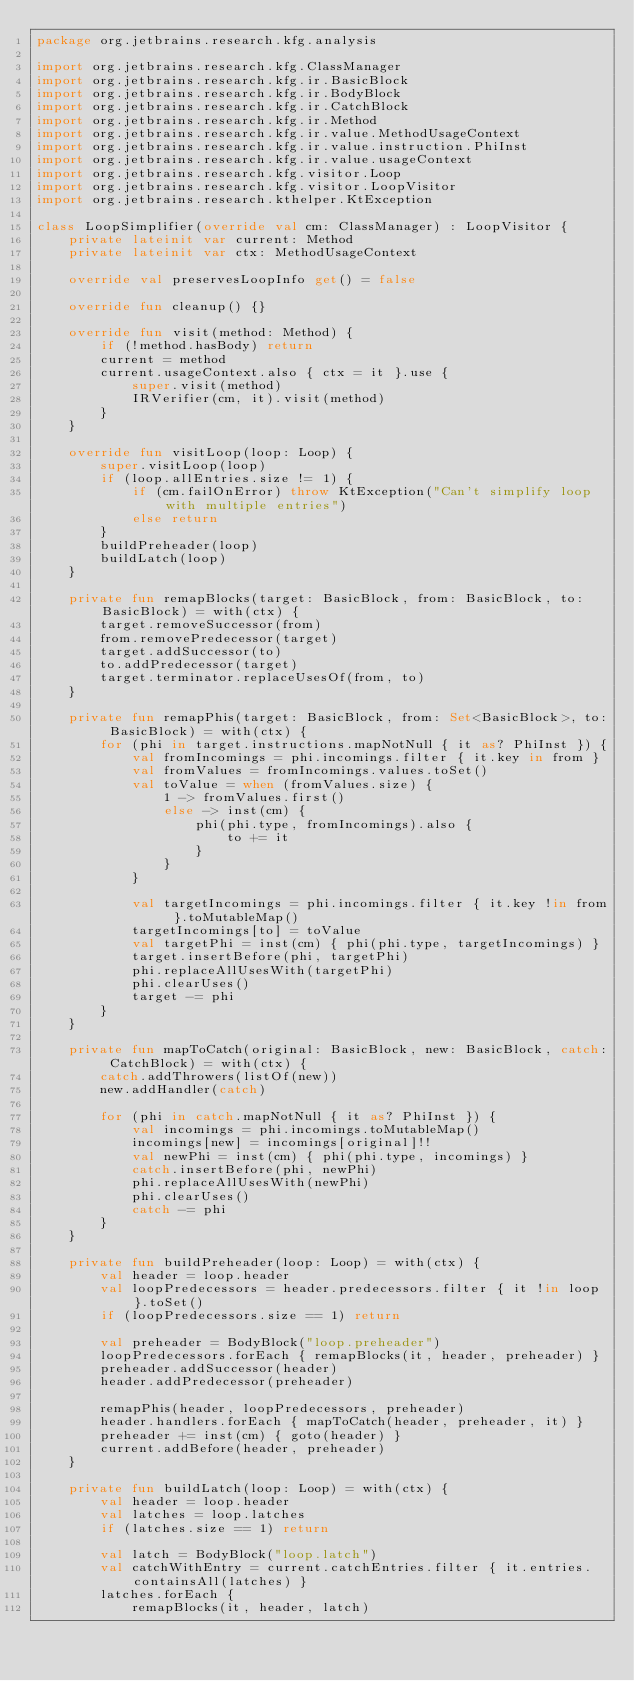<code> <loc_0><loc_0><loc_500><loc_500><_Kotlin_>package org.jetbrains.research.kfg.analysis

import org.jetbrains.research.kfg.ClassManager
import org.jetbrains.research.kfg.ir.BasicBlock
import org.jetbrains.research.kfg.ir.BodyBlock
import org.jetbrains.research.kfg.ir.CatchBlock
import org.jetbrains.research.kfg.ir.Method
import org.jetbrains.research.kfg.ir.value.MethodUsageContext
import org.jetbrains.research.kfg.ir.value.instruction.PhiInst
import org.jetbrains.research.kfg.ir.value.usageContext
import org.jetbrains.research.kfg.visitor.Loop
import org.jetbrains.research.kfg.visitor.LoopVisitor
import org.jetbrains.research.kthelper.KtException

class LoopSimplifier(override val cm: ClassManager) : LoopVisitor {
    private lateinit var current: Method
    private lateinit var ctx: MethodUsageContext

    override val preservesLoopInfo get() = false

    override fun cleanup() {}

    override fun visit(method: Method) {
        if (!method.hasBody) return
        current = method
        current.usageContext.also { ctx = it }.use {
            super.visit(method)
            IRVerifier(cm, it).visit(method)
        }
    }

    override fun visitLoop(loop: Loop) {
        super.visitLoop(loop)
        if (loop.allEntries.size != 1) {
            if (cm.failOnError) throw KtException("Can't simplify loop with multiple entries")
            else return
        }
        buildPreheader(loop)
        buildLatch(loop)
    }

    private fun remapBlocks(target: BasicBlock, from: BasicBlock, to: BasicBlock) = with(ctx) {
        target.removeSuccessor(from)
        from.removePredecessor(target)
        target.addSuccessor(to)
        to.addPredecessor(target)
        target.terminator.replaceUsesOf(from, to)
    }

    private fun remapPhis(target: BasicBlock, from: Set<BasicBlock>, to: BasicBlock) = with(ctx) {
        for (phi in target.instructions.mapNotNull { it as? PhiInst }) {
            val fromIncomings = phi.incomings.filter { it.key in from }
            val fromValues = fromIncomings.values.toSet()
            val toValue = when (fromValues.size) {
                1 -> fromValues.first()
                else -> inst(cm) {
                    phi(phi.type, fromIncomings).also {
                        to += it
                    }
                }
            }

            val targetIncomings = phi.incomings.filter { it.key !in from }.toMutableMap()
            targetIncomings[to] = toValue
            val targetPhi = inst(cm) { phi(phi.type, targetIncomings) }
            target.insertBefore(phi, targetPhi)
            phi.replaceAllUsesWith(targetPhi)
            phi.clearUses()
            target -= phi
        }
    }

    private fun mapToCatch(original: BasicBlock, new: BasicBlock, catch: CatchBlock) = with(ctx) {
        catch.addThrowers(listOf(new))
        new.addHandler(catch)

        for (phi in catch.mapNotNull { it as? PhiInst }) {
            val incomings = phi.incomings.toMutableMap()
            incomings[new] = incomings[original]!!
            val newPhi = inst(cm) { phi(phi.type, incomings) }
            catch.insertBefore(phi, newPhi)
            phi.replaceAllUsesWith(newPhi)
            phi.clearUses()
            catch -= phi
        }
    }

    private fun buildPreheader(loop: Loop) = with(ctx) {
        val header = loop.header
        val loopPredecessors = header.predecessors.filter { it !in loop }.toSet()
        if (loopPredecessors.size == 1) return

        val preheader = BodyBlock("loop.preheader")
        loopPredecessors.forEach { remapBlocks(it, header, preheader) }
        preheader.addSuccessor(header)
        header.addPredecessor(preheader)

        remapPhis(header, loopPredecessors, preheader)
        header.handlers.forEach { mapToCatch(header, preheader, it) }
        preheader += inst(cm) { goto(header) }
        current.addBefore(header, preheader)
    }

    private fun buildLatch(loop: Loop) = with(ctx) {
        val header = loop.header
        val latches = loop.latches
        if (latches.size == 1) return

        val latch = BodyBlock("loop.latch")
        val catchWithEntry = current.catchEntries.filter { it.entries.containsAll(latches) }
        latches.forEach {
            remapBlocks(it, header, latch)</code> 